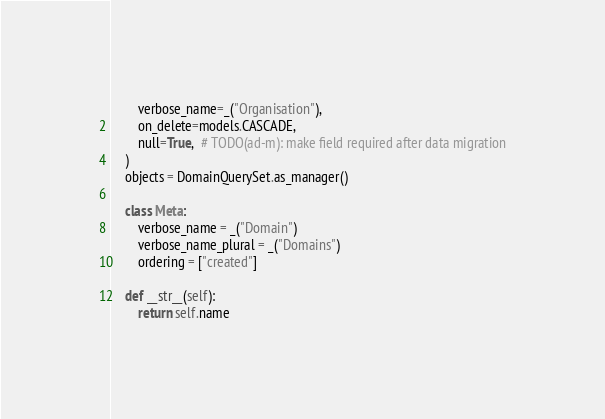Convert code to text. <code><loc_0><loc_0><loc_500><loc_500><_Python_>        verbose_name=_("Organisation"),
        on_delete=models.CASCADE,
        null=True,  # TODO(ad-m): make field required after data migration
    )
    objects = DomainQuerySet.as_manager()

    class Meta:
        verbose_name = _("Domain")
        verbose_name_plural = _("Domains")
        ordering = ["created"]

    def __str__(self):
        return self.name
</code> 